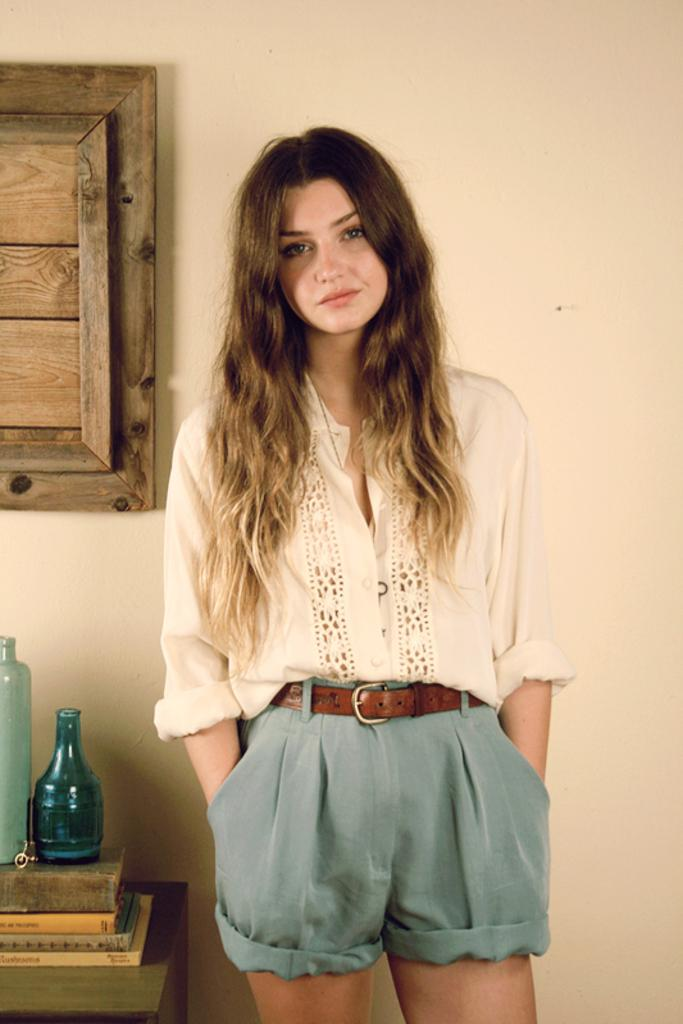What is the main subject of the image? There is a person standing in the center of the image. What can be seen on the left side of the image? There is a table on the left side of the image. How many bottles are on the table? There are two bottles on the table. What can be seen in the background of the image? There is a wall and wood visible in the background of the image. What type of smell can be detected in the image? There is no information about smells in the image, so it cannot be determined from the image. 